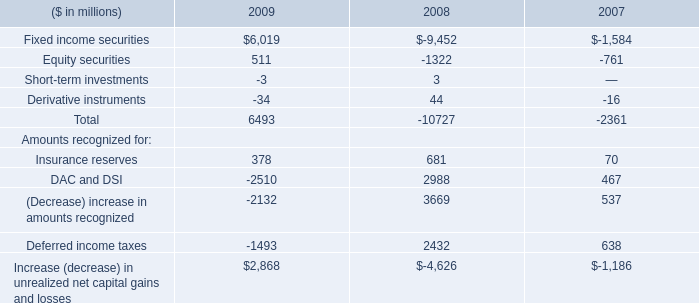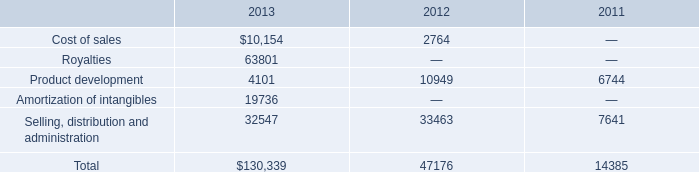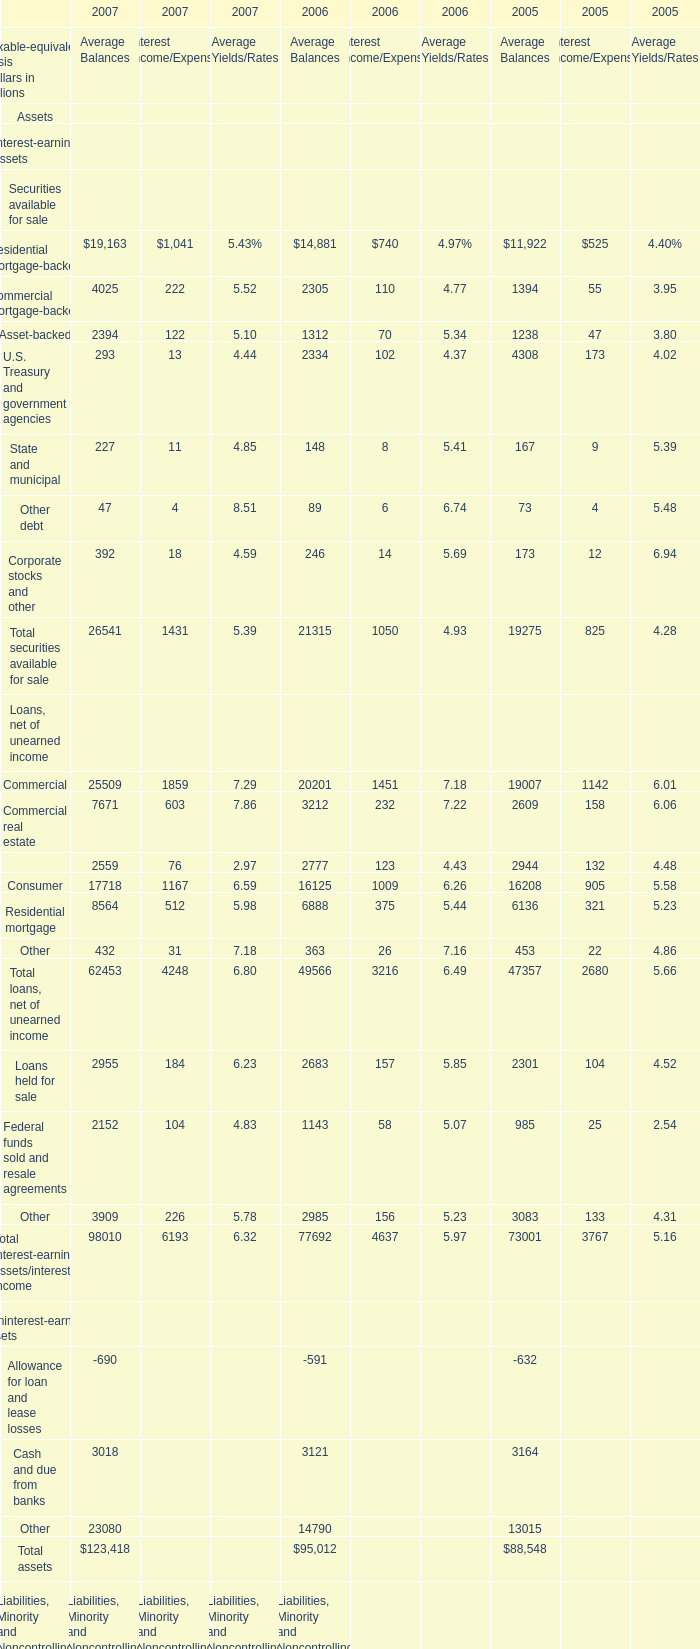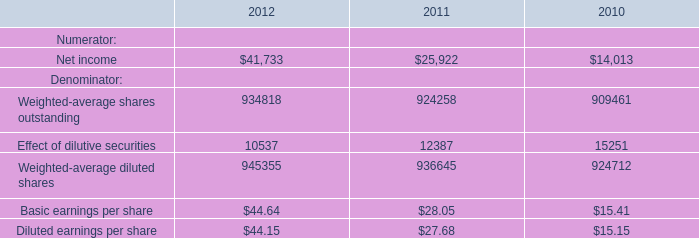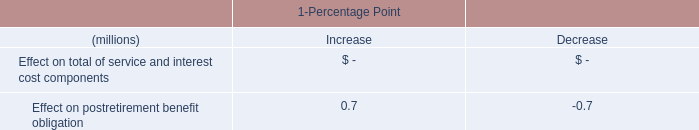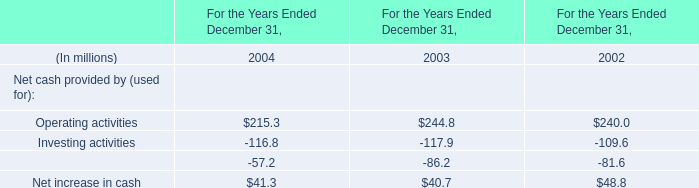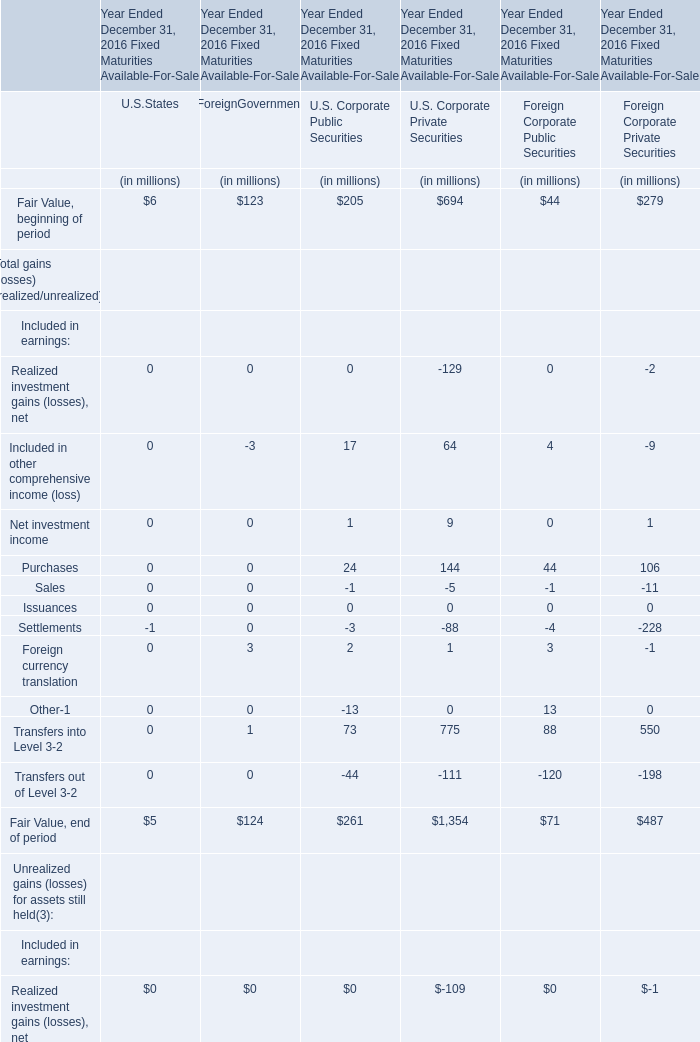What is the sum of Fair Value, end of period in the range of 1 and 200 in 2016 ? 
Computations: ((5 + 124) + 71)
Answer: 200.0. 